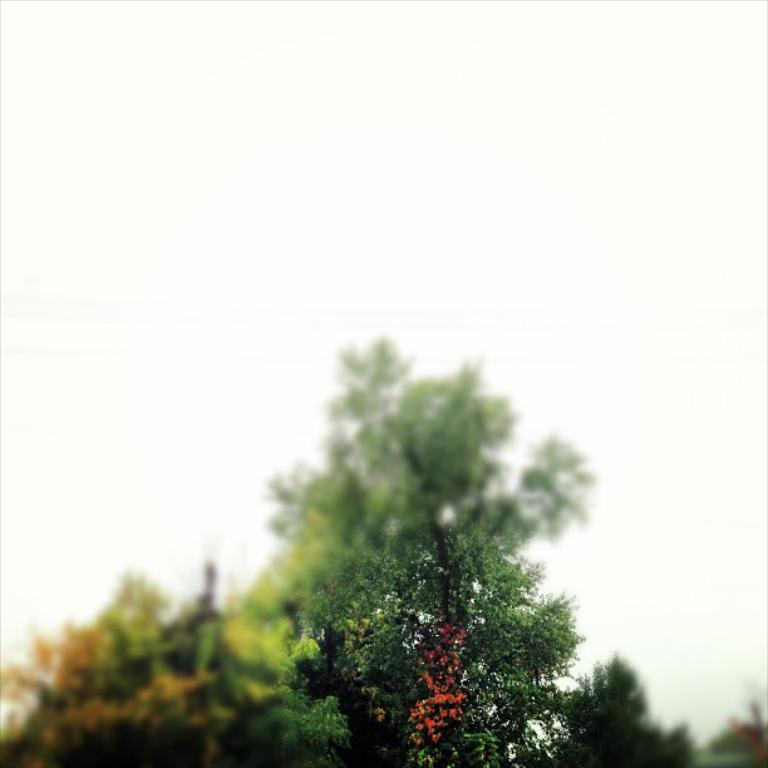What type of vegetation can be seen in the image? There are trees in the image. What color is the background of the image? The background of the image appears to be white. How would you describe the clarity of the image? The image is slightly blurry. What type of smell can be detected in the image? There is no information about smells in the image, as it only provides visual information. 